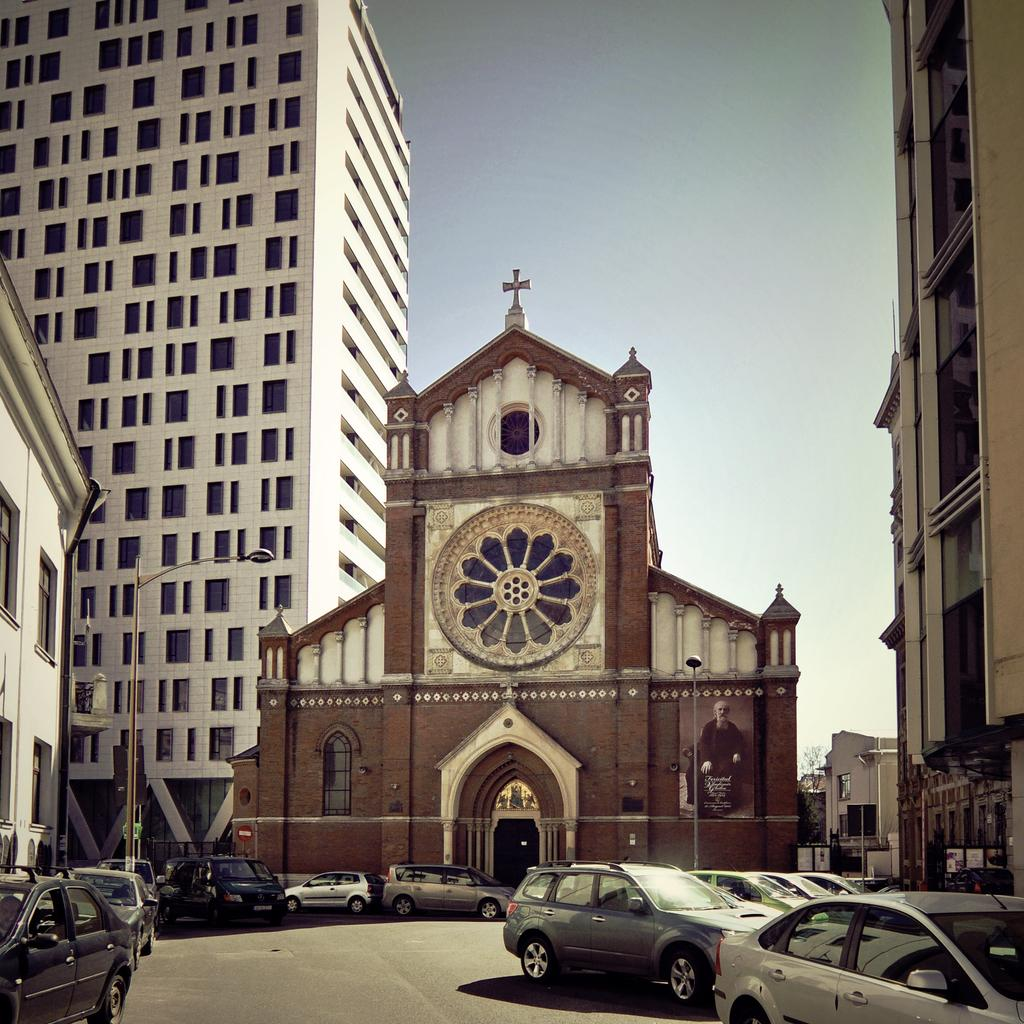What can be seen on the road in the image? There are vehicles on the road in the image. What structures are present along the road? Light poles are present in the image. What type of man-made structures can be seen in the image? Buildings are visible in the image. What natural element is present in the image? There is a tree in the image. What is visible in the background of the image? The sky is visible in the background of the image. What type of plant is the manager watering in the image? There is no plant or manager present in the image; it features vehicles, light poles, buildings, a tree, and the sky. 